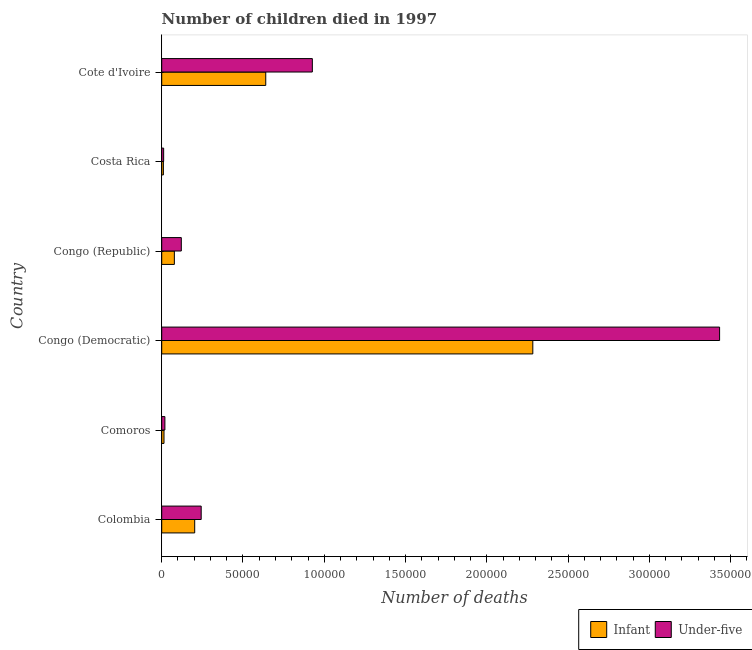How many different coloured bars are there?
Your response must be concise. 2. How many groups of bars are there?
Offer a terse response. 6. Are the number of bars per tick equal to the number of legend labels?
Your response must be concise. Yes. Are the number of bars on each tick of the Y-axis equal?
Ensure brevity in your answer.  Yes. How many bars are there on the 4th tick from the top?
Keep it short and to the point. 2. What is the label of the 1st group of bars from the top?
Give a very brief answer. Cote d'Ivoire. What is the number of under-five deaths in Colombia?
Make the answer very short. 2.43e+04. Across all countries, what is the maximum number of infant deaths?
Keep it short and to the point. 2.28e+05. Across all countries, what is the minimum number of infant deaths?
Provide a succinct answer. 1026. In which country was the number of infant deaths maximum?
Keep it short and to the point. Congo (Democratic). In which country was the number of under-five deaths minimum?
Your answer should be very brief. Costa Rica. What is the total number of under-five deaths in the graph?
Ensure brevity in your answer.  4.75e+05. What is the difference between the number of under-five deaths in Congo (Democratic) and that in Cote d'Ivoire?
Your response must be concise. 2.51e+05. What is the difference between the number of under-five deaths in Colombia and the number of infant deaths in Cote d'Ivoire?
Give a very brief answer. -3.97e+04. What is the average number of infant deaths per country?
Provide a succinct answer. 5.38e+04. What is the difference between the number of under-five deaths and number of infant deaths in Comoros?
Make the answer very short. 545. What is the ratio of the number of under-five deaths in Colombia to that in Comoros?
Make the answer very short. 12.44. What is the difference between the highest and the second highest number of infant deaths?
Give a very brief answer. 1.64e+05. What is the difference between the highest and the lowest number of under-five deaths?
Give a very brief answer. 3.42e+05. In how many countries, is the number of under-five deaths greater than the average number of under-five deaths taken over all countries?
Your answer should be very brief. 2. Is the sum of the number of infant deaths in Comoros and Costa Rica greater than the maximum number of under-five deaths across all countries?
Ensure brevity in your answer.  No. What does the 2nd bar from the top in Colombia represents?
Provide a short and direct response. Infant. What does the 2nd bar from the bottom in Congo (Republic) represents?
Provide a succinct answer. Under-five. How many bars are there?
Ensure brevity in your answer.  12. Does the graph contain any zero values?
Give a very brief answer. No. How many legend labels are there?
Give a very brief answer. 2. What is the title of the graph?
Provide a short and direct response. Number of children died in 1997. What is the label or title of the X-axis?
Offer a terse response. Number of deaths. What is the label or title of the Y-axis?
Provide a succinct answer. Country. What is the Number of deaths of Infant in Colombia?
Your answer should be compact. 2.03e+04. What is the Number of deaths in Under-five in Colombia?
Your answer should be very brief. 2.43e+04. What is the Number of deaths of Infant in Comoros?
Offer a terse response. 1407. What is the Number of deaths of Under-five in Comoros?
Provide a succinct answer. 1952. What is the Number of deaths of Infant in Congo (Democratic)?
Provide a short and direct response. 2.28e+05. What is the Number of deaths of Under-five in Congo (Democratic)?
Ensure brevity in your answer.  3.43e+05. What is the Number of deaths in Infant in Congo (Republic)?
Offer a terse response. 7783. What is the Number of deaths in Under-five in Congo (Republic)?
Offer a terse response. 1.21e+04. What is the Number of deaths of Infant in Costa Rica?
Your response must be concise. 1026. What is the Number of deaths in Under-five in Costa Rica?
Your answer should be very brief. 1198. What is the Number of deaths of Infant in Cote d'Ivoire?
Provide a short and direct response. 6.40e+04. What is the Number of deaths in Under-five in Cote d'Ivoire?
Your answer should be compact. 9.27e+04. Across all countries, what is the maximum Number of deaths of Infant?
Provide a short and direct response. 2.28e+05. Across all countries, what is the maximum Number of deaths in Under-five?
Keep it short and to the point. 3.43e+05. Across all countries, what is the minimum Number of deaths of Infant?
Give a very brief answer. 1026. Across all countries, what is the minimum Number of deaths in Under-five?
Your answer should be compact. 1198. What is the total Number of deaths of Infant in the graph?
Provide a succinct answer. 3.23e+05. What is the total Number of deaths of Under-five in the graph?
Your answer should be compact. 4.75e+05. What is the difference between the Number of deaths in Infant in Colombia and that in Comoros?
Your response must be concise. 1.89e+04. What is the difference between the Number of deaths of Under-five in Colombia and that in Comoros?
Your answer should be compact. 2.23e+04. What is the difference between the Number of deaths in Infant in Colombia and that in Congo (Democratic)?
Give a very brief answer. -2.08e+05. What is the difference between the Number of deaths in Under-five in Colombia and that in Congo (Democratic)?
Your response must be concise. -3.19e+05. What is the difference between the Number of deaths in Infant in Colombia and that in Congo (Republic)?
Ensure brevity in your answer.  1.25e+04. What is the difference between the Number of deaths of Under-five in Colombia and that in Congo (Republic)?
Your response must be concise. 1.22e+04. What is the difference between the Number of deaths of Infant in Colombia and that in Costa Rica?
Provide a short and direct response. 1.93e+04. What is the difference between the Number of deaths of Under-five in Colombia and that in Costa Rica?
Ensure brevity in your answer.  2.31e+04. What is the difference between the Number of deaths of Infant in Colombia and that in Cote d'Ivoire?
Give a very brief answer. -4.37e+04. What is the difference between the Number of deaths in Under-five in Colombia and that in Cote d'Ivoire?
Your answer should be compact. -6.84e+04. What is the difference between the Number of deaths of Infant in Comoros and that in Congo (Democratic)?
Your answer should be compact. -2.27e+05. What is the difference between the Number of deaths of Under-five in Comoros and that in Congo (Democratic)?
Your answer should be very brief. -3.41e+05. What is the difference between the Number of deaths in Infant in Comoros and that in Congo (Republic)?
Your answer should be very brief. -6376. What is the difference between the Number of deaths in Under-five in Comoros and that in Congo (Republic)?
Provide a succinct answer. -1.01e+04. What is the difference between the Number of deaths in Infant in Comoros and that in Costa Rica?
Your answer should be compact. 381. What is the difference between the Number of deaths in Under-five in Comoros and that in Costa Rica?
Your answer should be compact. 754. What is the difference between the Number of deaths in Infant in Comoros and that in Cote d'Ivoire?
Your answer should be compact. -6.26e+04. What is the difference between the Number of deaths of Under-five in Comoros and that in Cote d'Ivoire?
Offer a very short reply. -9.07e+04. What is the difference between the Number of deaths in Infant in Congo (Democratic) and that in Congo (Republic)?
Offer a very short reply. 2.21e+05. What is the difference between the Number of deaths of Under-five in Congo (Democratic) and that in Congo (Republic)?
Keep it short and to the point. 3.31e+05. What is the difference between the Number of deaths of Infant in Congo (Democratic) and that in Costa Rica?
Make the answer very short. 2.27e+05. What is the difference between the Number of deaths of Under-five in Congo (Democratic) and that in Costa Rica?
Offer a very short reply. 3.42e+05. What is the difference between the Number of deaths of Infant in Congo (Democratic) and that in Cote d'Ivoire?
Provide a succinct answer. 1.64e+05. What is the difference between the Number of deaths of Under-five in Congo (Democratic) and that in Cote d'Ivoire?
Keep it short and to the point. 2.51e+05. What is the difference between the Number of deaths of Infant in Congo (Republic) and that in Costa Rica?
Your response must be concise. 6757. What is the difference between the Number of deaths of Under-five in Congo (Republic) and that in Costa Rica?
Your answer should be very brief. 1.09e+04. What is the difference between the Number of deaths in Infant in Congo (Republic) and that in Cote d'Ivoire?
Make the answer very short. -5.62e+04. What is the difference between the Number of deaths of Under-five in Congo (Republic) and that in Cote d'Ivoire?
Offer a terse response. -8.06e+04. What is the difference between the Number of deaths in Infant in Costa Rica and that in Cote d'Ivoire?
Keep it short and to the point. -6.30e+04. What is the difference between the Number of deaths in Under-five in Costa Rica and that in Cote d'Ivoire?
Give a very brief answer. -9.15e+04. What is the difference between the Number of deaths in Infant in Colombia and the Number of deaths in Under-five in Comoros?
Offer a terse response. 1.83e+04. What is the difference between the Number of deaths of Infant in Colombia and the Number of deaths of Under-five in Congo (Democratic)?
Keep it short and to the point. -3.23e+05. What is the difference between the Number of deaths in Infant in Colombia and the Number of deaths in Under-five in Congo (Republic)?
Your answer should be very brief. 8236. What is the difference between the Number of deaths of Infant in Colombia and the Number of deaths of Under-five in Costa Rica?
Your answer should be compact. 1.91e+04. What is the difference between the Number of deaths of Infant in Colombia and the Number of deaths of Under-five in Cote d'Ivoire?
Ensure brevity in your answer.  -7.24e+04. What is the difference between the Number of deaths in Infant in Comoros and the Number of deaths in Under-five in Congo (Democratic)?
Your response must be concise. -3.42e+05. What is the difference between the Number of deaths of Infant in Comoros and the Number of deaths of Under-five in Congo (Republic)?
Your answer should be very brief. -1.06e+04. What is the difference between the Number of deaths of Infant in Comoros and the Number of deaths of Under-five in Costa Rica?
Provide a short and direct response. 209. What is the difference between the Number of deaths in Infant in Comoros and the Number of deaths in Under-five in Cote d'Ivoire?
Offer a very short reply. -9.13e+04. What is the difference between the Number of deaths in Infant in Congo (Democratic) and the Number of deaths in Under-five in Congo (Republic)?
Offer a terse response. 2.16e+05. What is the difference between the Number of deaths of Infant in Congo (Democratic) and the Number of deaths of Under-five in Costa Rica?
Keep it short and to the point. 2.27e+05. What is the difference between the Number of deaths in Infant in Congo (Democratic) and the Number of deaths in Under-five in Cote d'Ivoire?
Provide a succinct answer. 1.36e+05. What is the difference between the Number of deaths in Infant in Congo (Republic) and the Number of deaths in Under-five in Costa Rica?
Keep it short and to the point. 6585. What is the difference between the Number of deaths in Infant in Congo (Republic) and the Number of deaths in Under-five in Cote d'Ivoire?
Provide a succinct answer. -8.49e+04. What is the difference between the Number of deaths of Infant in Costa Rica and the Number of deaths of Under-five in Cote d'Ivoire?
Make the answer very short. -9.16e+04. What is the average Number of deaths of Infant per country?
Offer a very short reply. 5.38e+04. What is the average Number of deaths in Under-five per country?
Make the answer very short. 7.92e+04. What is the difference between the Number of deaths of Infant and Number of deaths of Under-five in Colombia?
Offer a terse response. -3995. What is the difference between the Number of deaths in Infant and Number of deaths in Under-five in Comoros?
Provide a succinct answer. -545. What is the difference between the Number of deaths of Infant and Number of deaths of Under-five in Congo (Democratic)?
Make the answer very short. -1.15e+05. What is the difference between the Number of deaths of Infant and Number of deaths of Under-five in Congo (Republic)?
Your answer should be very brief. -4274. What is the difference between the Number of deaths of Infant and Number of deaths of Under-five in Costa Rica?
Make the answer very short. -172. What is the difference between the Number of deaths in Infant and Number of deaths in Under-five in Cote d'Ivoire?
Your response must be concise. -2.87e+04. What is the ratio of the Number of deaths in Infant in Colombia to that in Comoros?
Your answer should be compact. 14.42. What is the ratio of the Number of deaths in Under-five in Colombia to that in Comoros?
Make the answer very short. 12.44. What is the ratio of the Number of deaths in Infant in Colombia to that in Congo (Democratic)?
Make the answer very short. 0.09. What is the ratio of the Number of deaths of Under-five in Colombia to that in Congo (Democratic)?
Offer a very short reply. 0.07. What is the ratio of the Number of deaths of Infant in Colombia to that in Congo (Republic)?
Offer a terse response. 2.61. What is the ratio of the Number of deaths in Under-five in Colombia to that in Congo (Republic)?
Make the answer very short. 2.01. What is the ratio of the Number of deaths of Infant in Colombia to that in Costa Rica?
Provide a short and direct response. 19.78. What is the ratio of the Number of deaths of Under-five in Colombia to that in Costa Rica?
Give a very brief answer. 20.27. What is the ratio of the Number of deaths of Infant in Colombia to that in Cote d'Ivoire?
Keep it short and to the point. 0.32. What is the ratio of the Number of deaths of Under-five in Colombia to that in Cote d'Ivoire?
Your answer should be very brief. 0.26. What is the ratio of the Number of deaths in Infant in Comoros to that in Congo (Democratic)?
Your response must be concise. 0.01. What is the ratio of the Number of deaths in Under-five in Comoros to that in Congo (Democratic)?
Offer a terse response. 0.01. What is the ratio of the Number of deaths of Infant in Comoros to that in Congo (Republic)?
Provide a short and direct response. 0.18. What is the ratio of the Number of deaths in Under-five in Comoros to that in Congo (Republic)?
Offer a terse response. 0.16. What is the ratio of the Number of deaths of Infant in Comoros to that in Costa Rica?
Your answer should be very brief. 1.37. What is the ratio of the Number of deaths of Under-five in Comoros to that in Costa Rica?
Your answer should be compact. 1.63. What is the ratio of the Number of deaths of Infant in Comoros to that in Cote d'Ivoire?
Your answer should be very brief. 0.02. What is the ratio of the Number of deaths in Under-five in Comoros to that in Cote d'Ivoire?
Ensure brevity in your answer.  0.02. What is the ratio of the Number of deaths of Infant in Congo (Democratic) to that in Congo (Republic)?
Your answer should be very brief. 29.33. What is the ratio of the Number of deaths in Under-five in Congo (Democratic) to that in Congo (Republic)?
Offer a terse response. 28.47. What is the ratio of the Number of deaths in Infant in Congo (Democratic) to that in Costa Rica?
Keep it short and to the point. 222.52. What is the ratio of the Number of deaths of Under-five in Congo (Democratic) to that in Costa Rica?
Give a very brief answer. 286.49. What is the ratio of the Number of deaths of Infant in Congo (Democratic) to that in Cote d'Ivoire?
Offer a very short reply. 3.57. What is the ratio of the Number of deaths in Under-five in Congo (Democratic) to that in Cote d'Ivoire?
Your answer should be compact. 3.7. What is the ratio of the Number of deaths of Infant in Congo (Republic) to that in Costa Rica?
Ensure brevity in your answer.  7.59. What is the ratio of the Number of deaths in Under-five in Congo (Republic) to that in Costa Rica?
Make the answer very short. 10.06. What is the ratio of the Number of deaths in Infant in Congo (Republic) to that in Cote d'Ivoire?
Keep it short and to the point. 0.12. What is the ratio of the Number of deaths of Under-five in Congo (Republic) to that in Cote d'Ivoire?
Your answer should be compact. 0.13. What is the ratio of the Number of deaths in Infant in Costa Rica to that in Cote d'Ivoire?
Your answer should be compact. 0.02. What is the ratio of the Number of deaths of Under-five in Costa Rica to that in Cote d'Ivoire?
Ensure brevity in your answer.  0.01. What is the difference between the highest and the second highest Number of deaths of Infant?
Make the answer very short. 1.64e+05. What is the difference between the highest and the second highest Number of deaths in Under-five?
Keep it short and to the point. 2.51e+05. What is the difference between the highest and the lowest Number of deaths in Infant?
Provide a succinct answer. 2.27e+05. What is the difference between the highest and the lowest Number of deaths in Under-five?
Your response must be concise. 3.42e+05. 